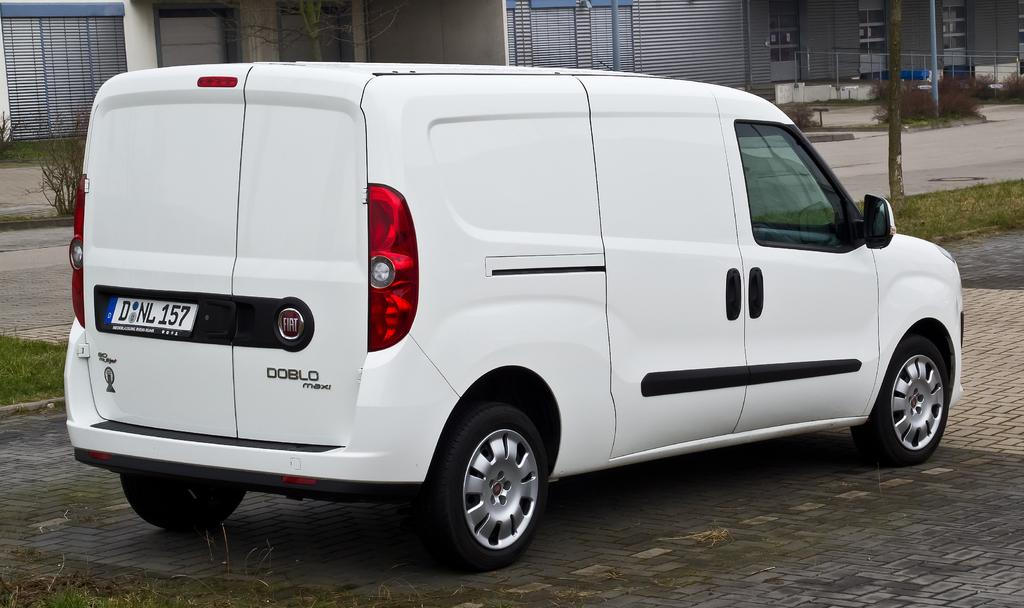<image>
Relay a brief, clear account of the picture shown. A DOBLO maxi van with license plate DNL 157 is parked 